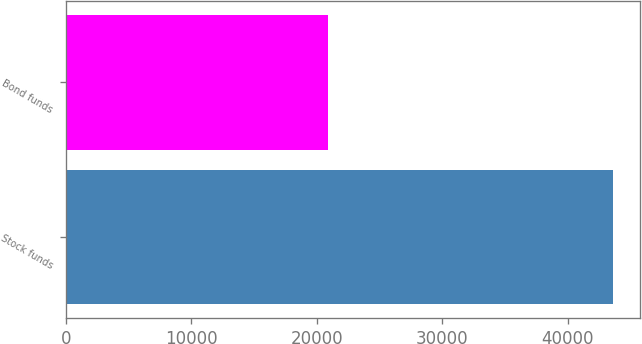<chart> <loc_0><loc_0><loc_500><loc_500><bar_chart><fcel>Stock funds<fcel>Bond funds<nl><fcel>43595<fcel>20894<nl></chart> 